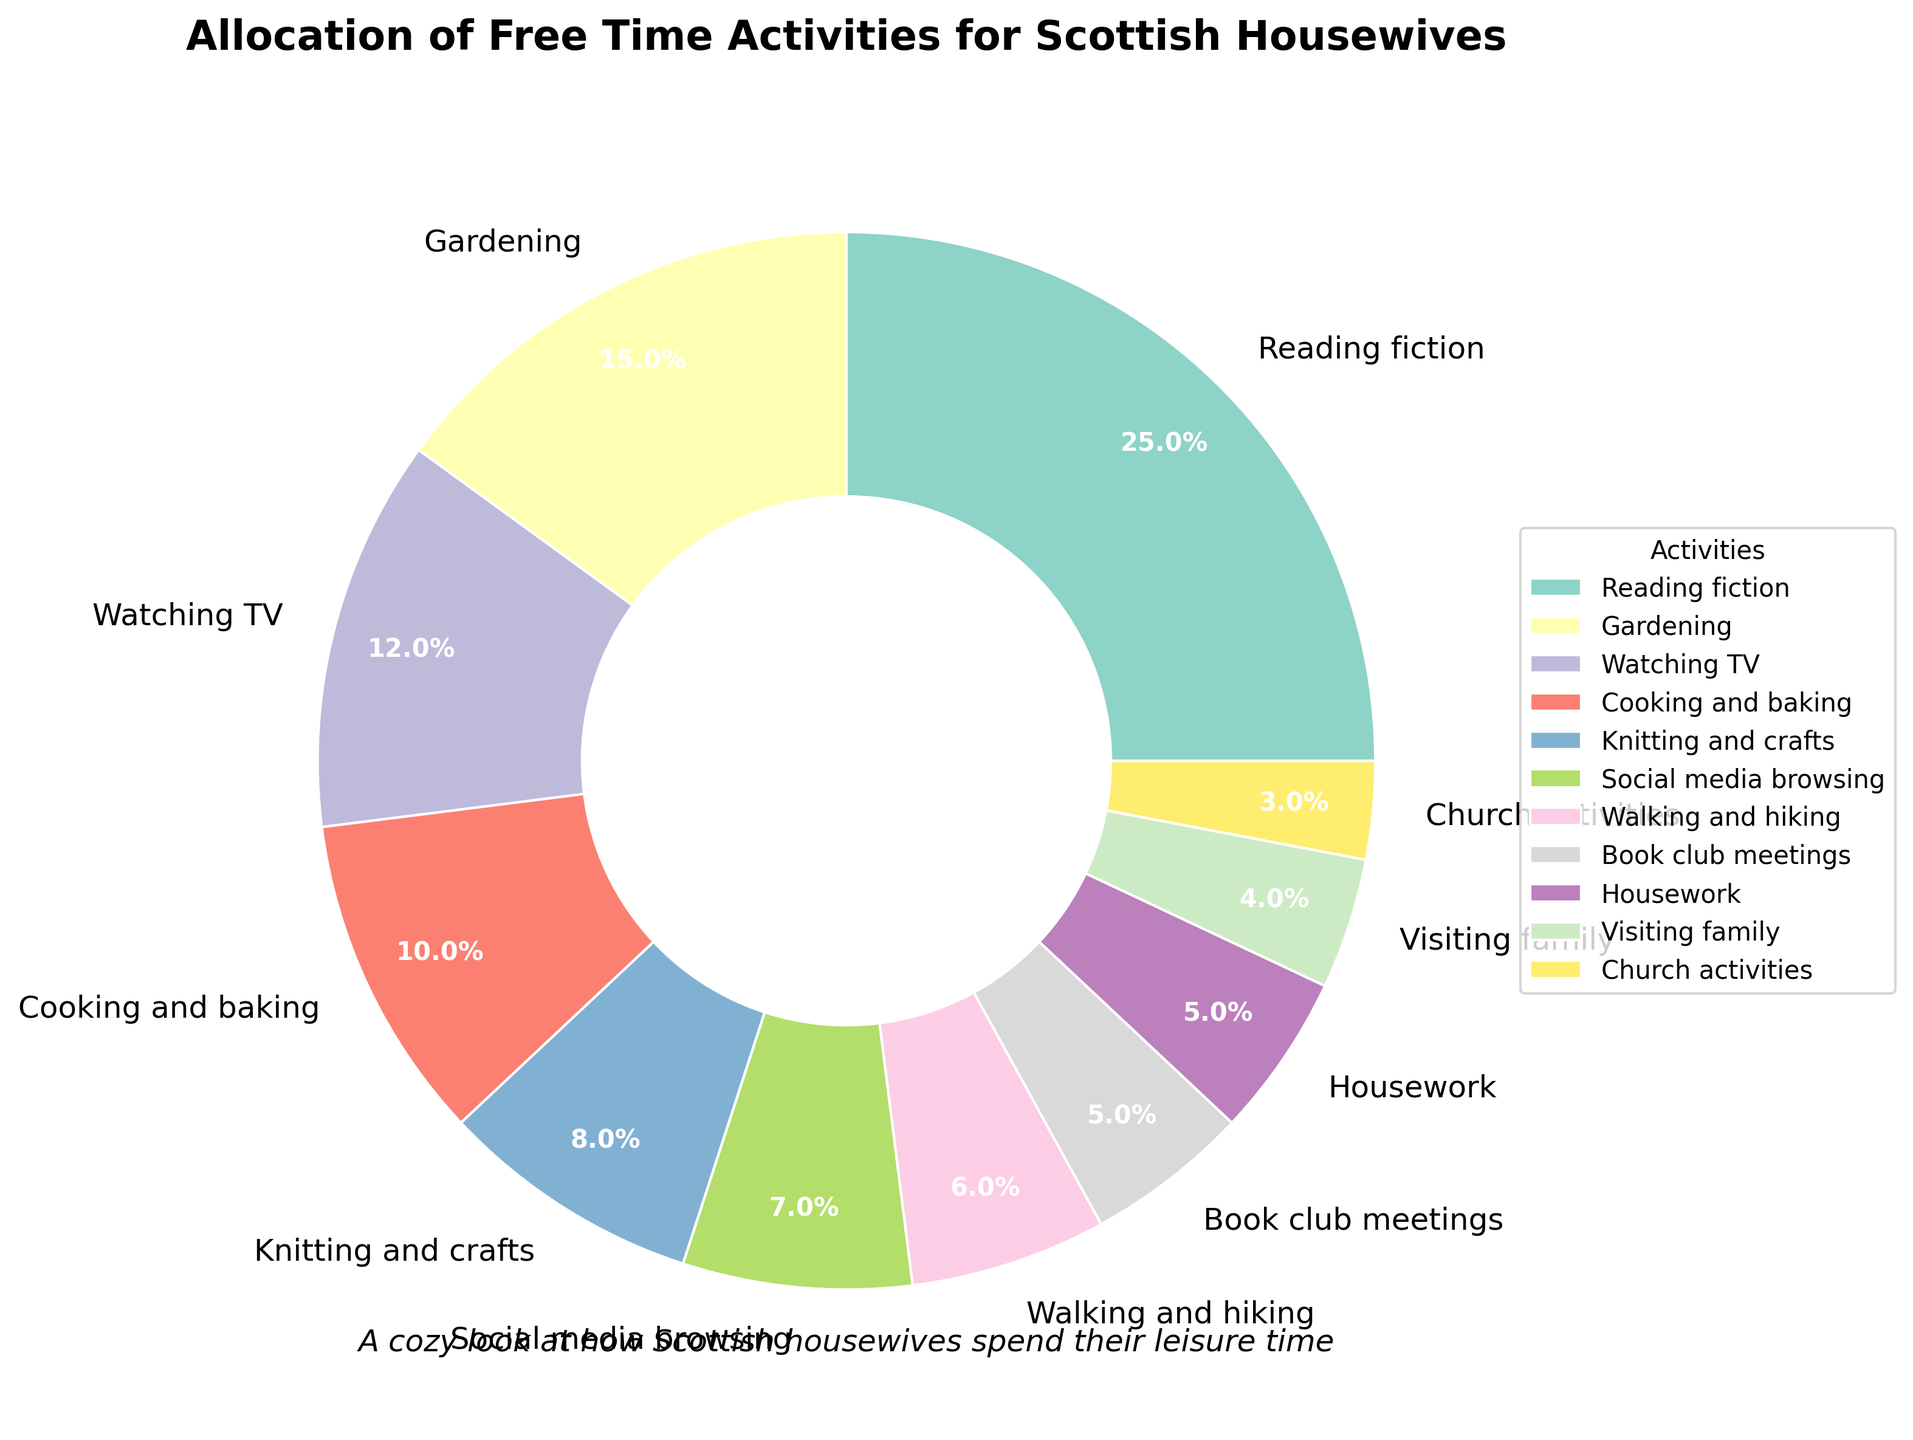What's the most popular free time activity among Scottish housewives? The pie chart shows the proportion of various activities. The largest wedge represents the most popular activity, which is Reading fiction at 25%.
Answer: Reading fiction How much more time is spent on Reading fiction than on Gardening? Reading fiction accounts for 25%, and Gardening accounts for 15%. The difference is calculated as 25% - 15% = 10%.
Answer: 10% Which activities together make up exactly half of the total free time? Combining activities until the cumulative sum reaches 50%: Reading fiction (25%) + Gardening (15%) + Watching TV (12%) = 25% + 15% + 12% = 52%. Since this exceeds 50%, we use Reading fiction (25%) + Gardening (15%) + Cooking and baking (10%) = 25% + 15% + 10% = 50%.
Answer: Reading fiction, Gardening, Cooking, and baking What is the least time-consuming activity in the pie chart? The smallest wedge represents the least time-consuming activity, which is Church activities at 3%.
Answer: Church activities By how many percentage points does the time spent on Walking and hiking exceed the time spent on Visiting family? Time spent on Walking and hiking is 6%, and on Visiting family is 4%. The difference is calculated as 6% - 4% = 2%.
Answer: 2% Which activity has a slice that is about half the size of the Reading fiction slice? Reading fiction's slice is 25%. Half of this is 12.5%. Watching TV's slice is closest at 12%.
Answer: Watching TV If we combine the percentages of Social media browsing and Church activities, will it exceed the time spent on Gardening? Social media browsing is 7%, and Church activities is 3%. Combined, they make 7% + 3% = 10%. Since 10% is less than 15%, it does not exceed Gardening.
Answer: No How much time is allocated to activities involving interacting with others (Social media browsing, Book club meetings, Visiting family, Church activities)? Social media browsing (7%) + Book club meetings (5%) + Visiting family (4%) + Church activities (3%) = 7% + 5% + 4% + 3% = 19%.
Answer: 19% What activities take more time than Knitting and crafts? Knitting and crafts accounts for 8%. The activities taking more time are Reading fiction (25%), Gardening (15%), Watching TV (12%), and Cooking and baking (10%).
Answer: Reading fiction, Gardening, Watching TV, Cooking and baking What is the combined percentage for housework and visiting family? Housework is 5%, and visiting family is 4%. The combined percentage is calculated as 5% + 4% = 9%.
Answer: 9% 